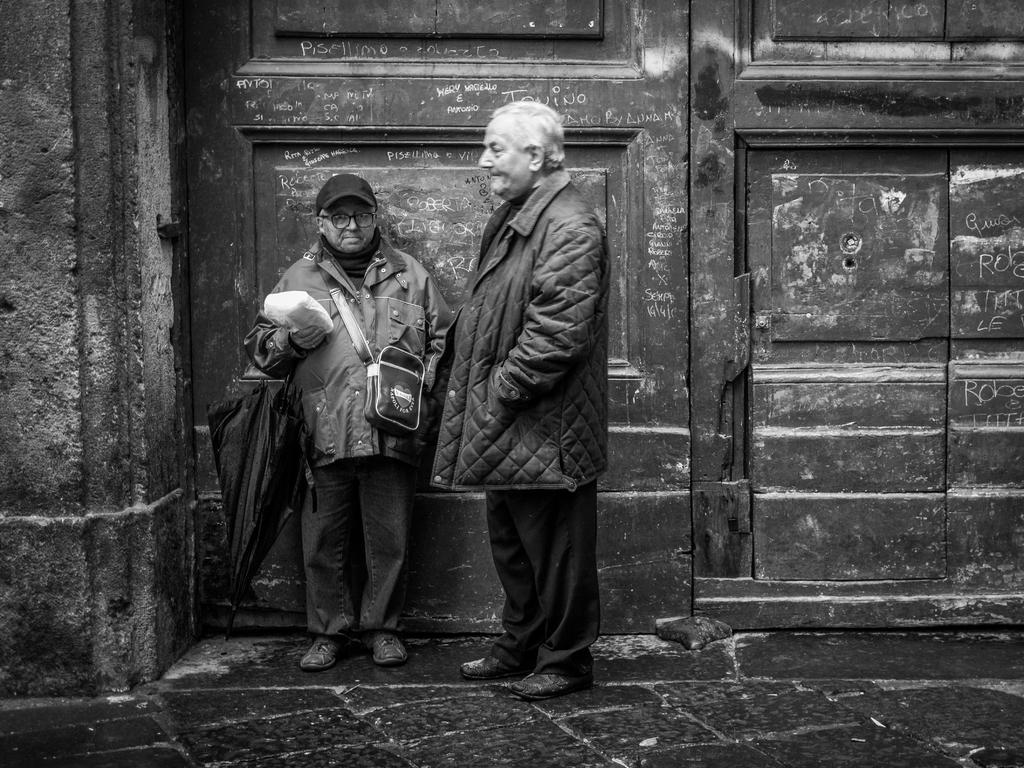How many men are present in the image? There are two men in the image. Where are the two men located in the image? The two men are standing in the middle of the image. What is visible in the background of the image? There is a wall in the background of the image. What type of sack can be seen in the image? There is no sack present in the image. Is there a volcano visible in the background of the image? No, there is no volcano visible in the image; it only features two men and a wall in the background. Can you tell me how many cellars are present in the image? There is no mention of a cellar in the image; it only features two men and a wall in the background. 